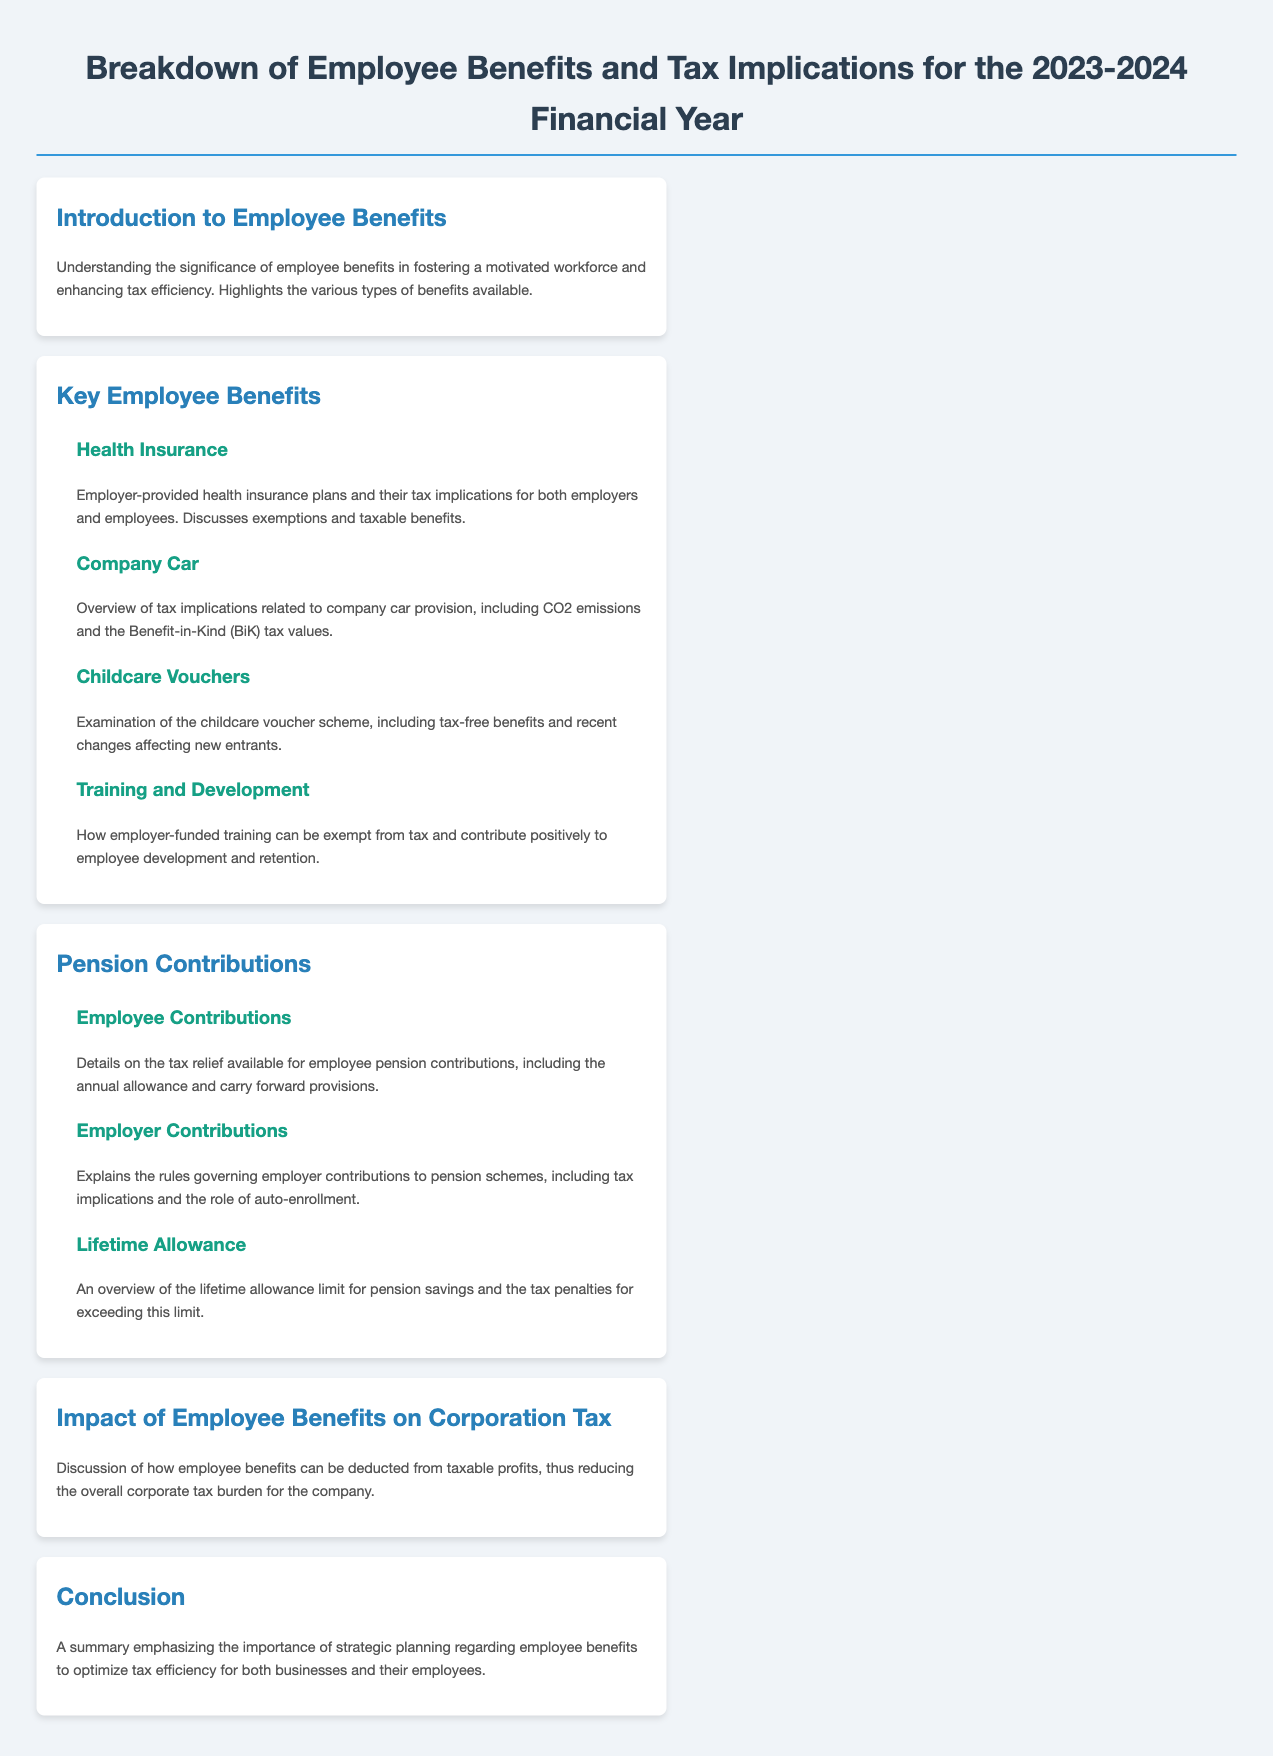What is the title of the document? The title of the document is presented at the top of the page and describes the content regarding employee benefits and tax implications for the specified financial year.
Answer: Breakdown of Employee Benefits and Tax Implications for the 2023-2024 Financial Year What type of benefits does the document discuss? The document highlights various types of employee benefits that can foster motivation and enhance tax efficiency, specifically enumerated under the key employee benefits section.
Answer: Key Employee Benefits What are the tax implications of health insurance? This section discusses employer-provided health insurance plans and their tax implications for both employers and employees, specifically mentioning exemptions and taxable benefits.
Answer: Exemptions and taxable benefits What is examined under childcare vouchers? The childcare voucher section covers the tax-free benefits related to the scheme and mentions important changes affecting new entrants to the program.
Answer: Tax-free benefits and recent changes What is the maximum contribution limit referred to in pension contributions? The lifetime allowance indicates the limit for pension savings beyond which tax penalties will apply, as outlined in the pension contributions section.
Answer: Lifetime allowance How do employee benefits affect corporation tax? The document summarizes how employee benefits can be deducted from taxable profits, leading to a reduction in overall corporate tax burden.
Answer: Deducted from taxable profits What employer responsibilities are mentioned in this menu? The rules regarding employer contributions to pension schemes are discussed, emphasizing tax implications and the role of auto-enrollment provisions.
Answer: Employer contributions and auto-enrollment 